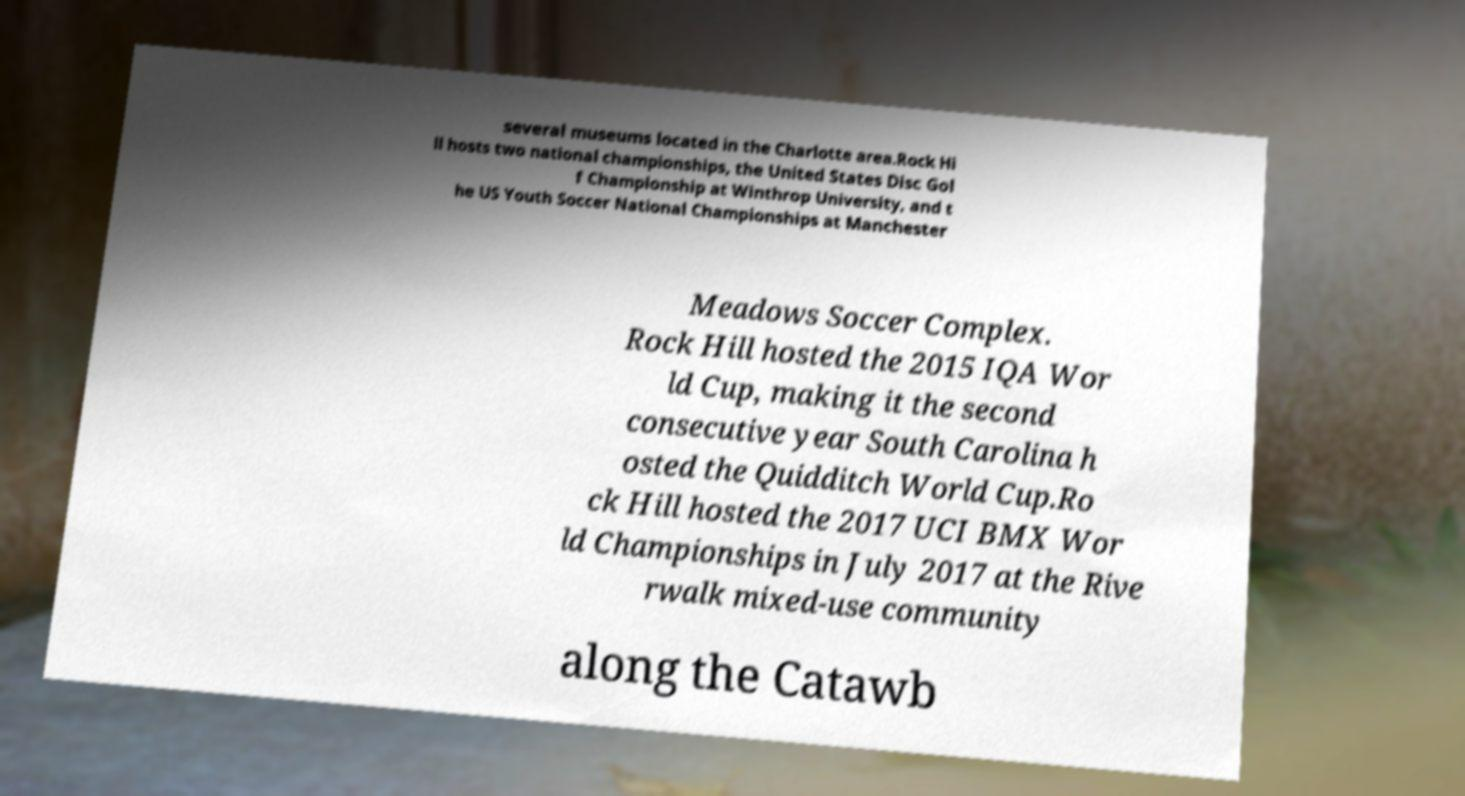Can you read and provide the text displayed in the image?This photo seems to have some interesting text. Can you extract and type it out for me? several museums located in the Charlotte area.Rock Hi ll hosts two national championships, the United States Disc Gol f Championship at Winthrop University, and t he US Youth Soccer National Championships at Manchester Meadows Soccer Complex. Rock Hill hosted the 2015 IQA Wor ld Cup, making it the second consecutive year South Carolina h osted the Quidditch World Cup.Ro ck Hill hosted the 2017 UCI BMX Wor ld Championships in July 2017 at the Rive rwalk mixed-use community along the Catawb 